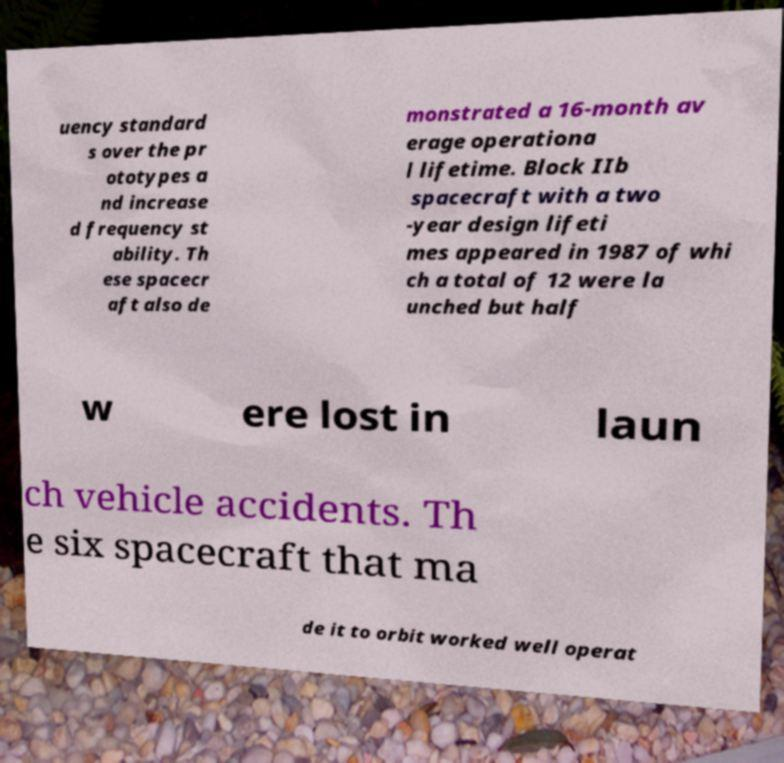What messages or text are displayed in this image? I need them in a readable, typed format. uency standard s over the pr ototypes a nd increase d frequency st ability. Th ese spacecr aft also de monstrated a 16-month av erage operationa l lifetime. Block IIb spacecraft with a two -year design lifeti mes appeared in 1987 of whi ch a total of 12 were la unched but half w ere lost in laun ch vehicle accidents. Th e six spacecraft that ma de it to orbit worked well operat 